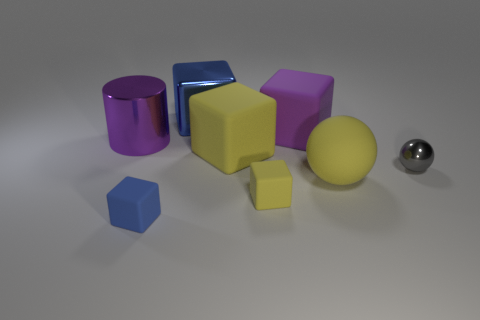Could you describe the lighting and shadows in the scene? The image is subtly lit from above with a soft light, resulting in gentle shadows beneath each object. The light source appears diffused, as there are no harsh lines or strong contrasts. The lighting gives the scene a calm and balanced appearance. 